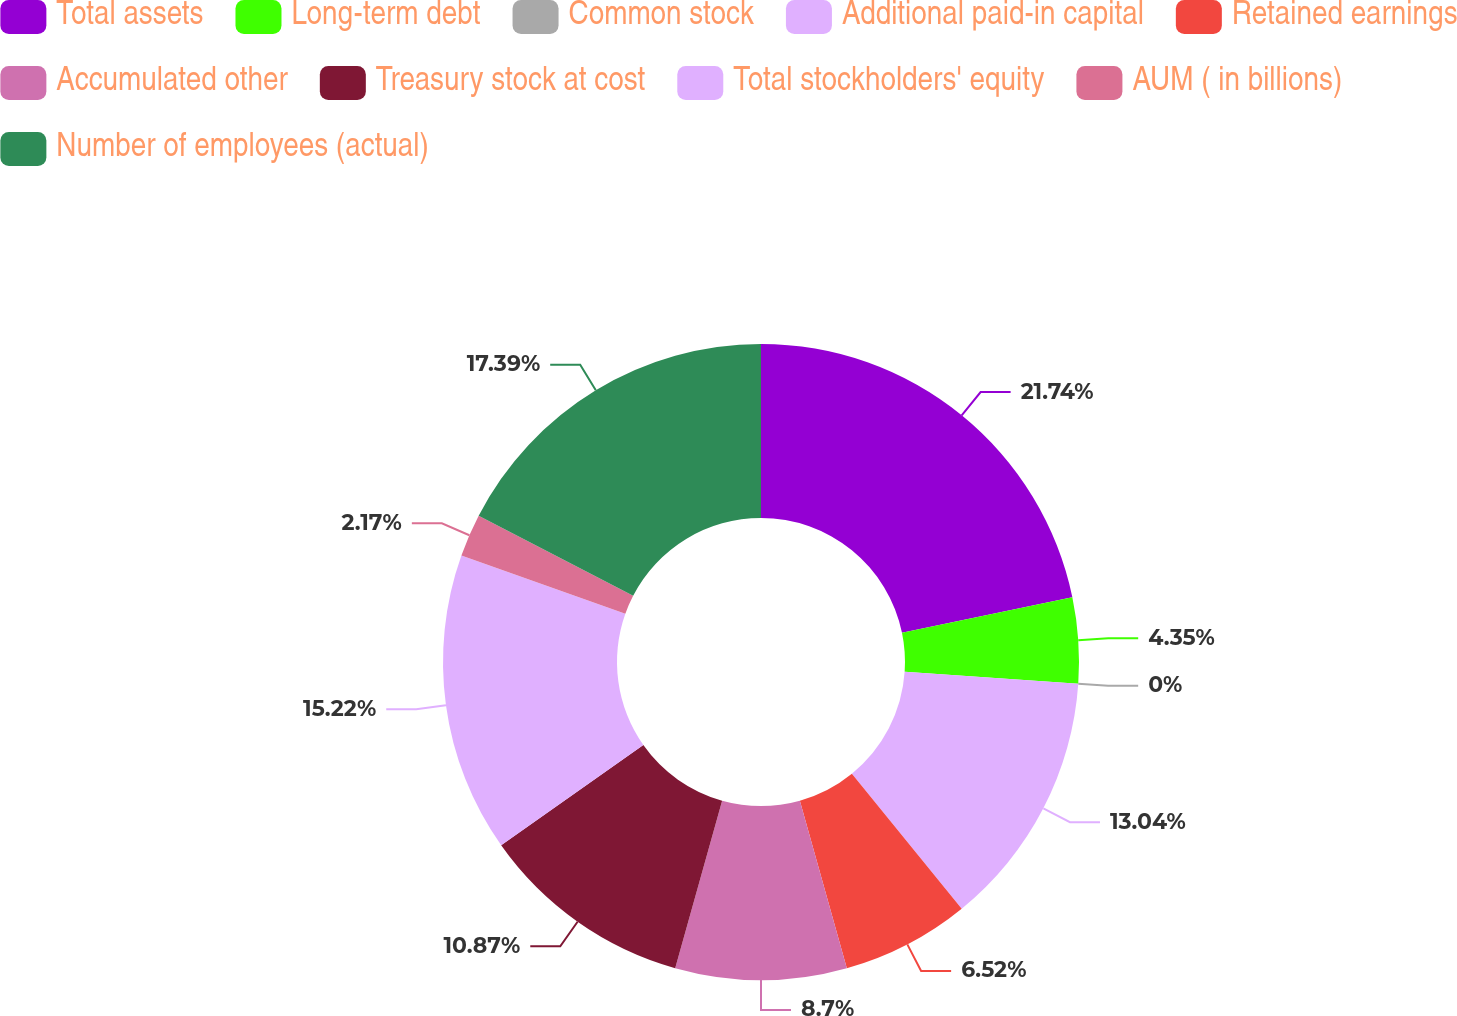<chart> <loc_0><loc_0><loc_500><loc_500><pie_chart><fcel>Total assets<fcel>Long-term debt<fcel>Common stock<fcel>Additional paid-in capital<fcel>Retained earnings<fcel>Accumulated other<fcel>Treasury stock at cost<fcel>Total stockholders' equity<fcel>AUM ( in billions)<fcel>Number of employees (actual)<nl><fcel>21.74%<fcel>4.35%<fcel>0.0%<fcel>13.04%<fcel>6.52%<fcel>8.7%<fcel>10.87%<fcel>15.22%<fcel>2.17%<fcel>17.39%<nl></chart> 